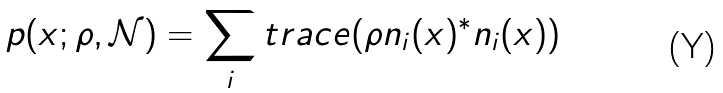Convert formula to latex. <formula><loc_0><loc_0><loc_500><loc_500>p ( x ; \rho , \mathcal { N } ) = \sum _ { i } t r a c e ( \rho n _ { i } ( x ) ^ { * } n _ { i } ( x ) )</formula> 